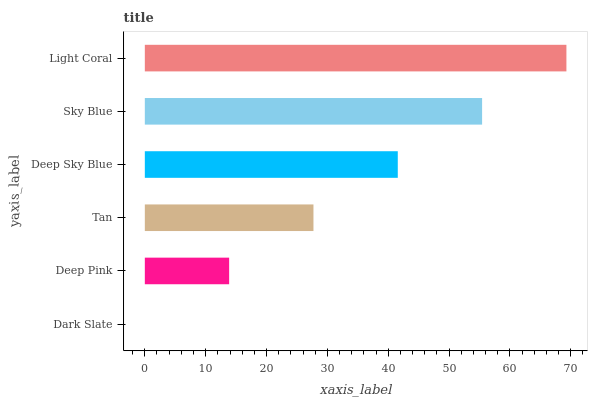Is Dark Slate the minimum?
Answer yes or no. Yes. Is Light Coral the maximum?
Answer yes or no. Yes. Is Deep Pink the minimum?
Answer yes or no. No. Is Deep Pink the maximum?
Answer yes or no. No. Is Deep Pink greater than Dark Slate?
Answer yes or no. Yes. Is Dark Slate less than Deep Pink?
Answer yes or no. Yes. Is Dark Slate greater than Deep Pink?
Answer yes or no. No. Is Deep Pink less than Dark Slate?
Answer yes or no. No. Is Deep Sky Blue the high median?
Answer yes or no. Yes. Is Tan the low median?
Answer yes or no. Yes. Is Deep Pink the high median?
Answer yes or no. No. Is Deep Pink the low median?
Answer yes or no. No. 